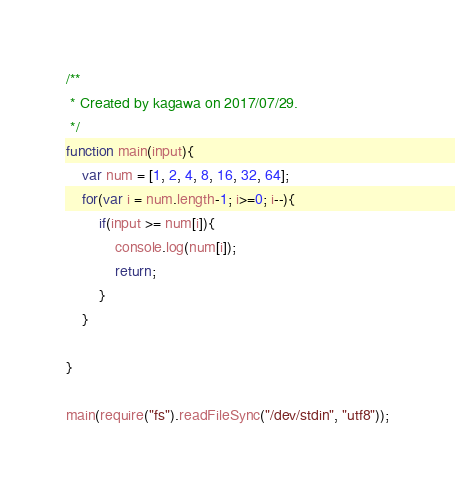Convert code to text. <code><loc_0><loc_0><loc_500><loc_500><_JavaScript_>/**
 * Created by kagawa on 2017/07/29.
 */
function main(input){
    var num = [1, 2, 4, 8, 16, 32, 64];
    for(var i = num.length-1; i>=0; i--){
        if(input >= num[i]){
            console.log(num[i]);
            return;
        }
    }

}

main(require("fs").readFileSync("/dev/stdin", "utf8"));</code> 